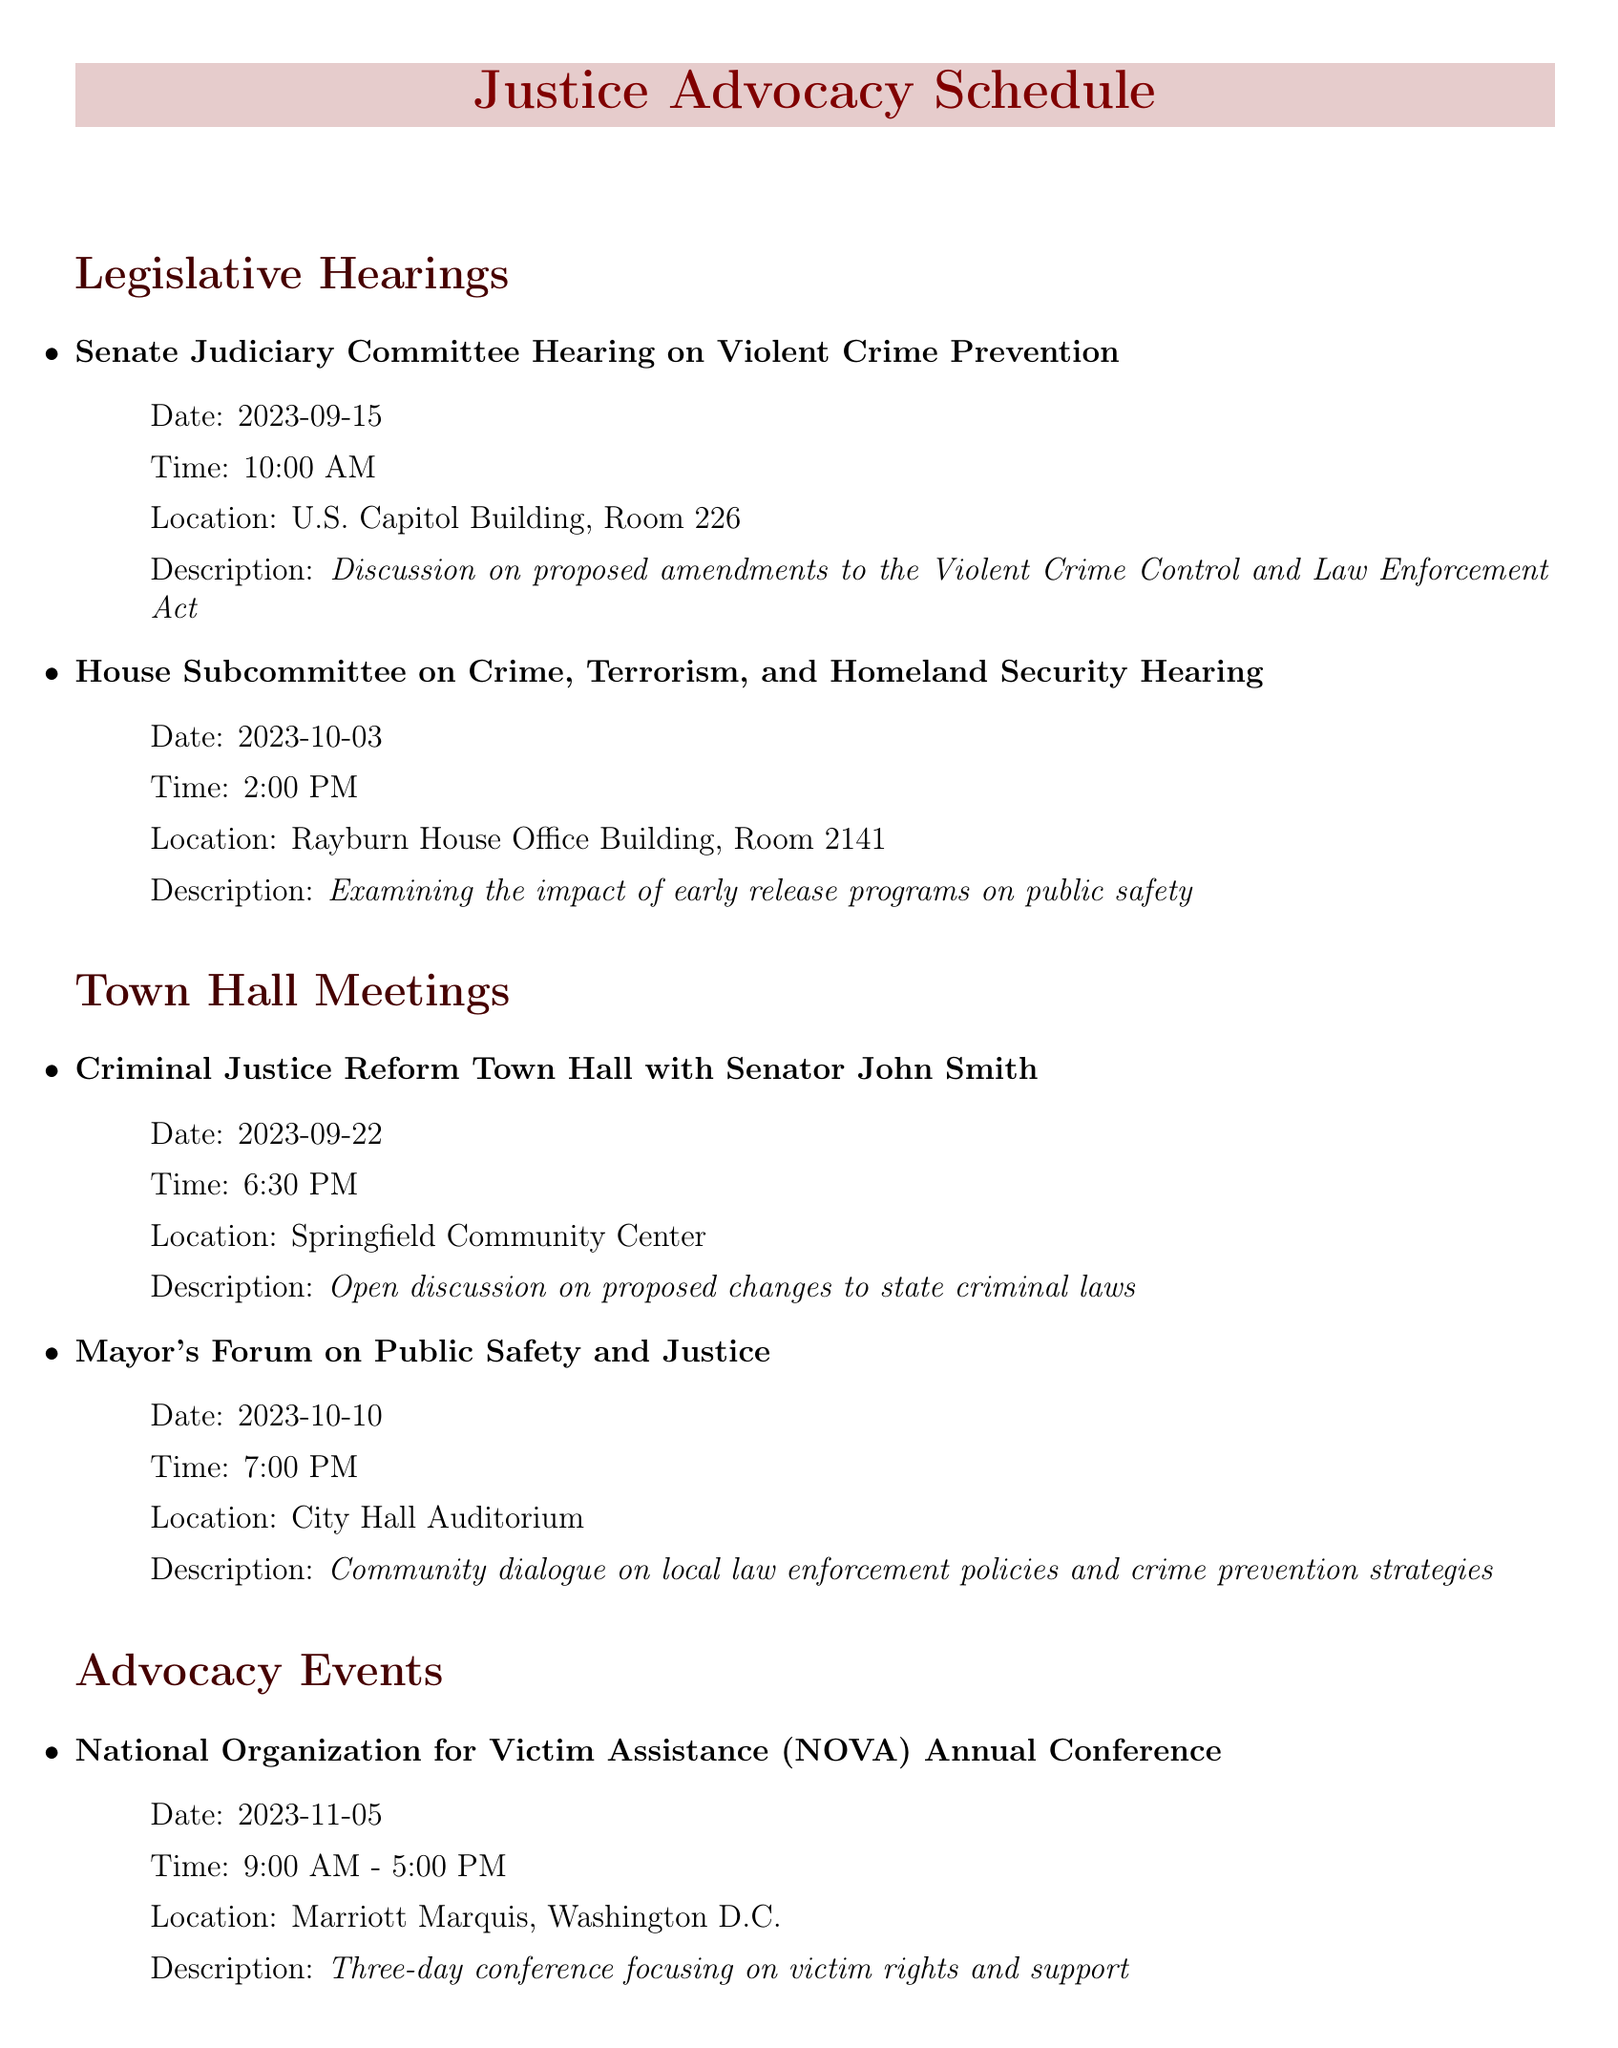What is the date of the Senate Judiciary Committee Hearing? The date is listed under the hearing details for the Senate Judiciary Committee, which is September 15, 2023.
Answer: September 15, 2023 What is the time for the House Subcommittee Hearing? The time is specified alongside the hearing details, which is 2:00 PM.
Answer: 2:00 PM Where will the Criminal Justice Reform Town Hall be held? The location is mentioned in the town hall details, which is Springfield Community Center.
Answer: Springfield Community Center What is the primary topic of discussion at the Mayor's Forum on Public Safety and Justice? The topic is outlined in the description of the event, focusing on local law enforcement policies.
Answer: Local law enforcement policies How many advocacy events are listed in the document? The number is determined by counting all the advocacy events mentioned, which totals four events.
Answer: Four Which event is scheduled for October 18, 2023? The event scheduled for this date is the workshop titled "Know Your Rights: Navigating the Criminal Justice System."
Answer: Know Your Rights: Navigating the Criminal Justice System What is the title of the event focusing on restorative justice? The title is found in the legal workshops section and is focused on comparing different justice approaches.
Answer: Restorative Justice vs. Retributive Justice Debate Which event offers a chance to share stories with DUI offenders? The event that provides this opportunity is identified in the advocacy events section, where victims share their stories.
Answer: Mothers Against Drunk Driving (MADD) Victim Impact Panel 